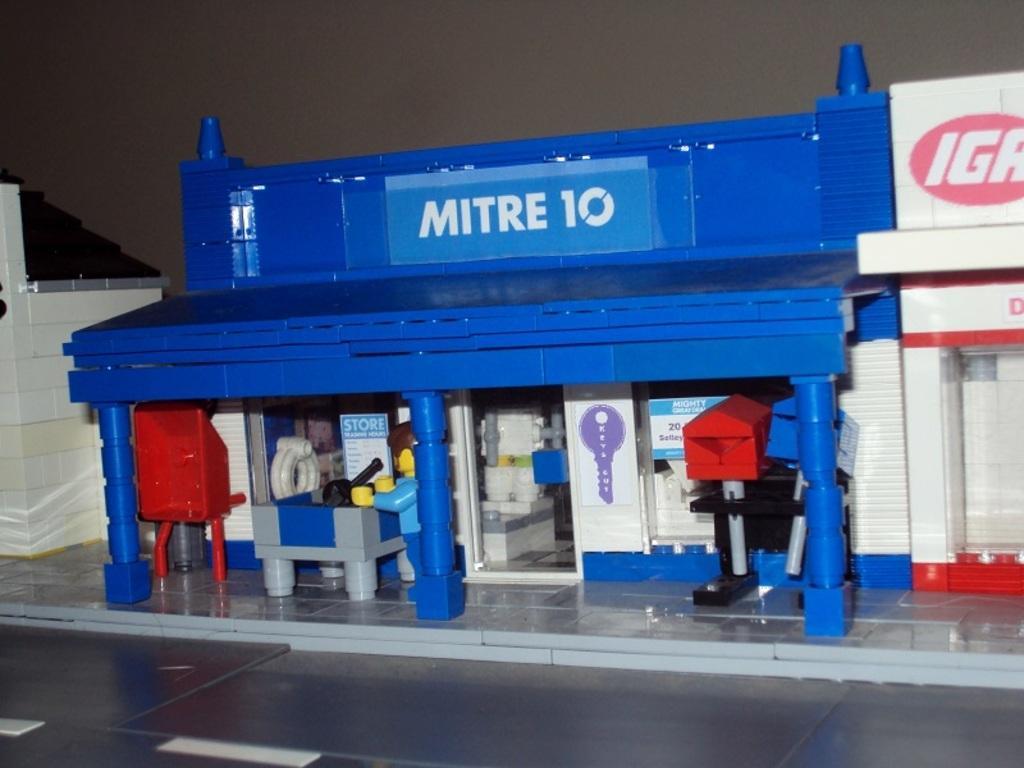Could you give a brief overview of what you see in this image? In this image we can see crafts build with legos. At the bottom there is a floor. In the background there is a wall. 